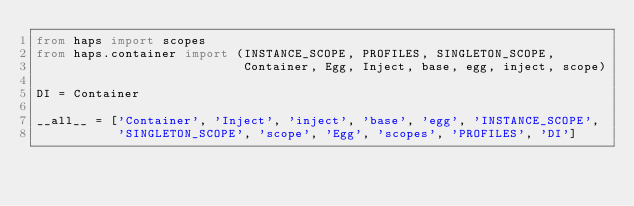Convert code to text. <code><loc_0><loc_0><loc_500><loc_500><_Python_>from haps import scopes
from haps.container import (INSTANCE_SCOPE, PROFILES, SINGLETON_SCOPE,
                            Container, Egg, Inject, base, egg, inject, scope)

DI = Container

__all__ = ['Container', 'Inject', 'inject', 'base', 'egg', 'INSTANCE_SCOPE',
           'SINGLETON_SCOPE', 'scope', 'Egg', 'scopes', 'PROFILES', 'DI']
</code> 